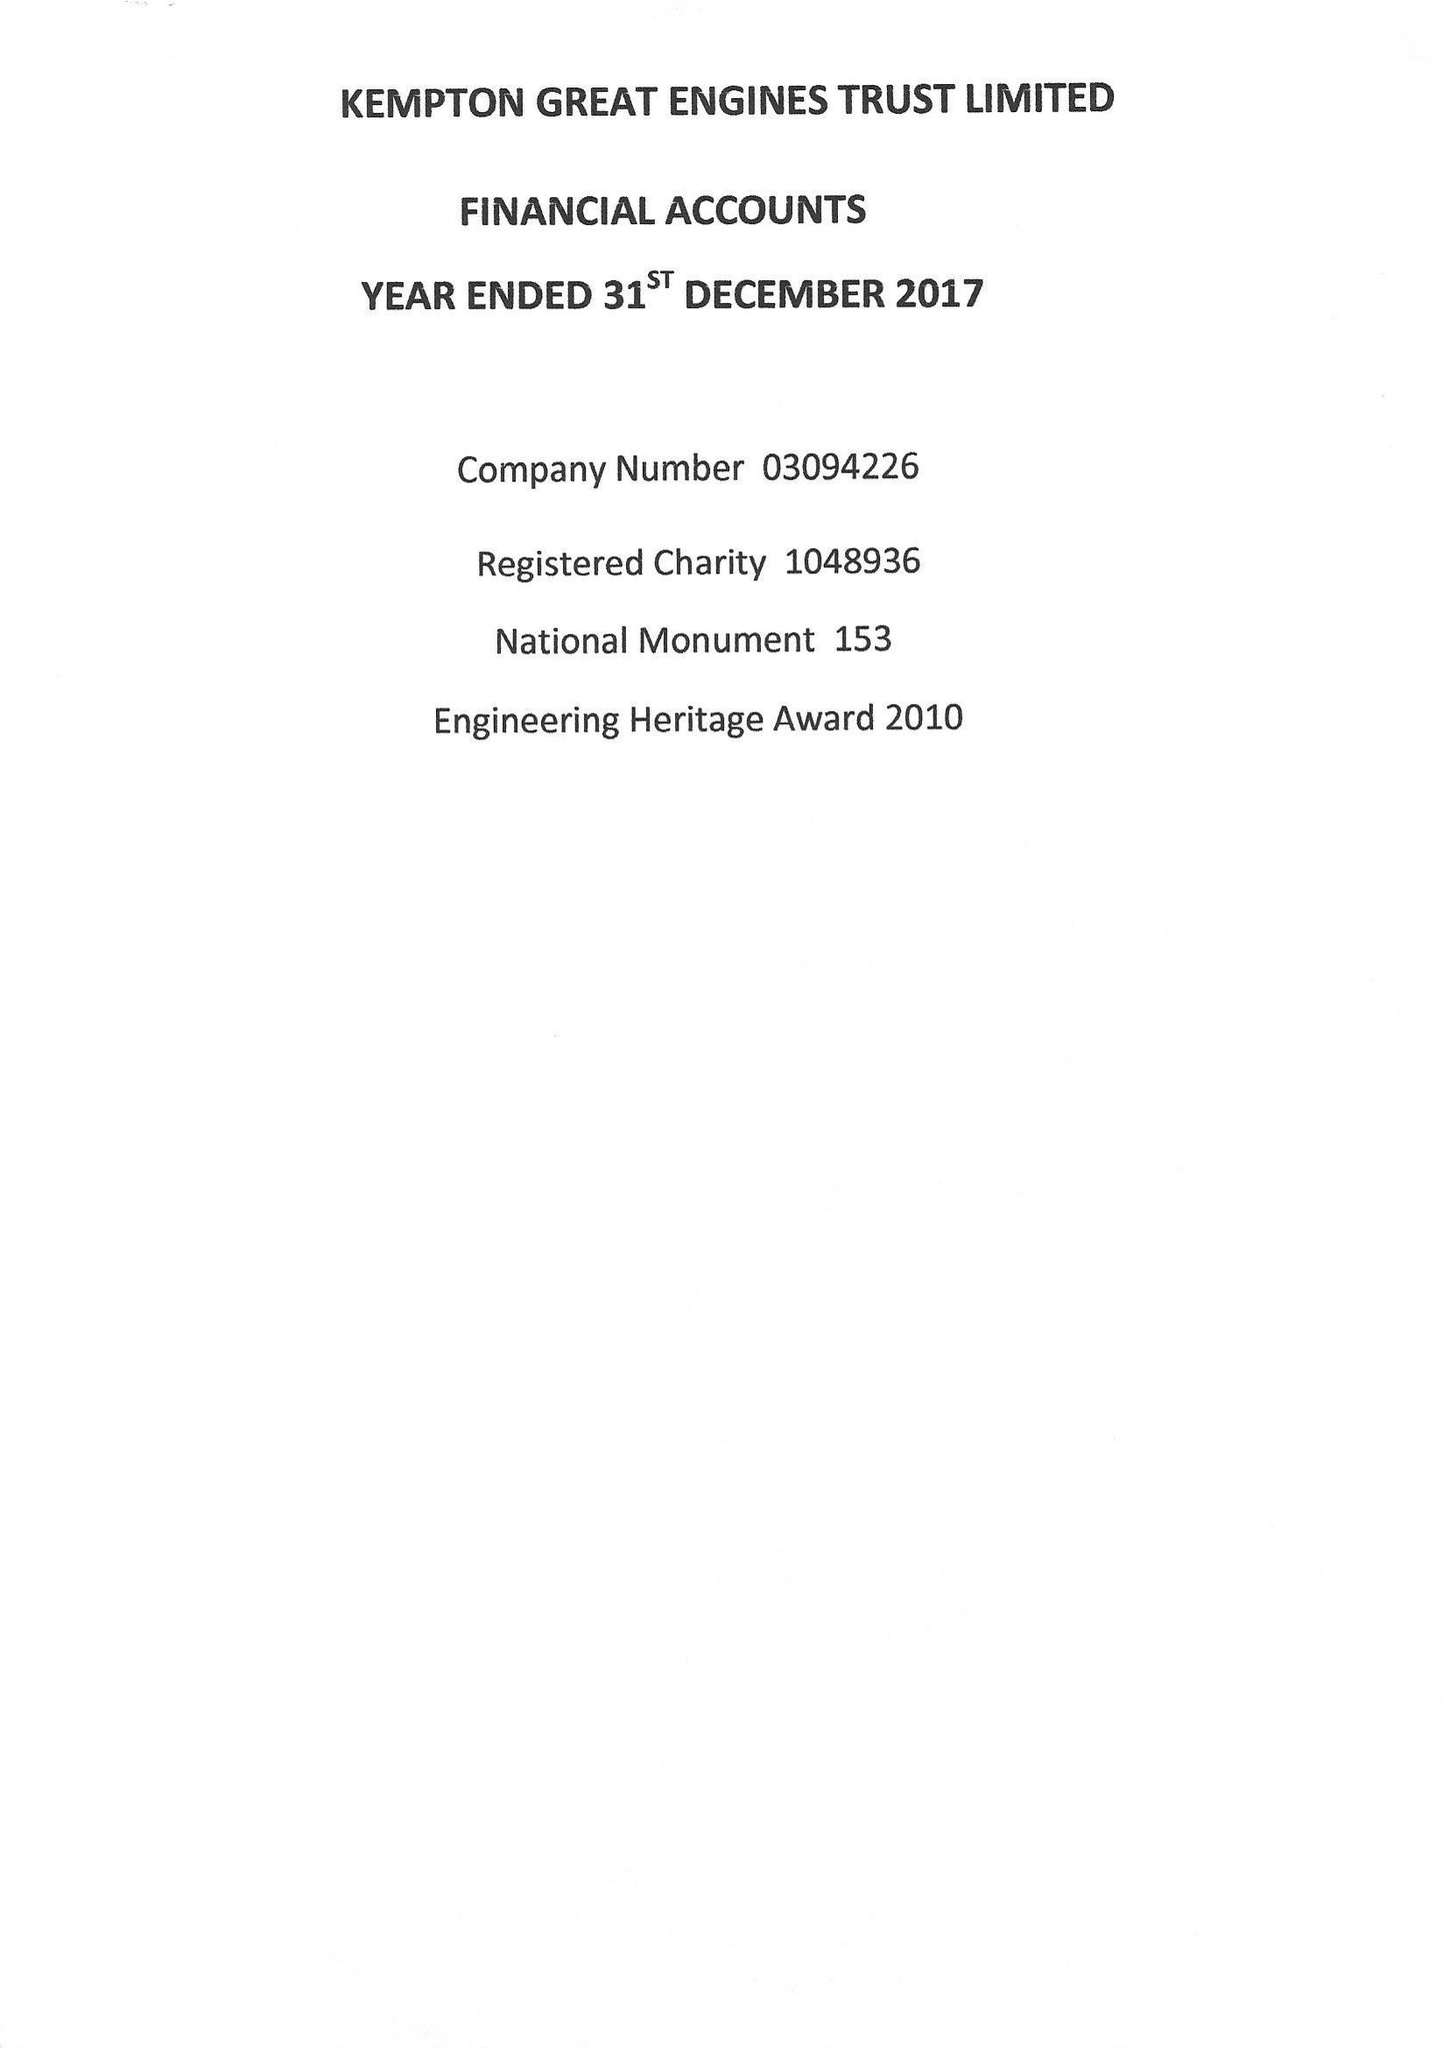What is the value for the charity_number?
Answer the question using a single word or phrase. 1048936 